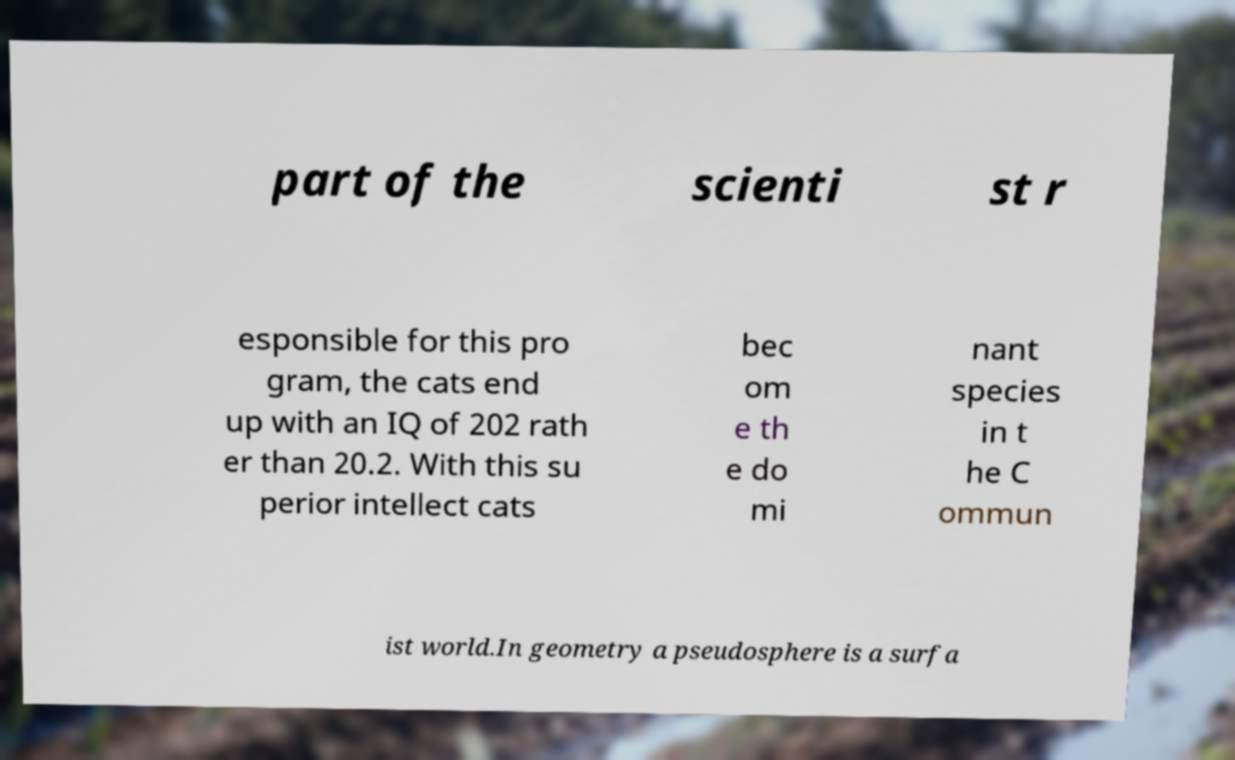Could you extract and type out the text from this image? part of the scienti st r esponsible for this pro gram, the cats end up with an IQ of 202 rath er than 20.2. With this su perior intellect cats bec om e th e do mi nant species in t he C ommun ist world.In geometry a pseudosphere is a surfa 